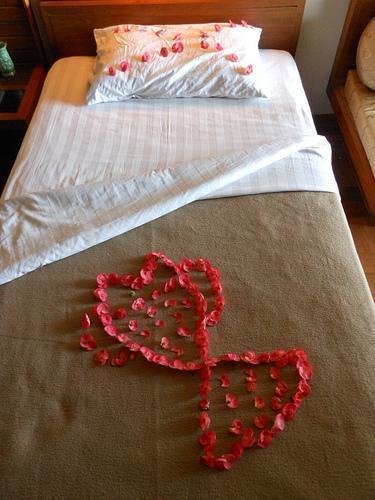How many pillows are on the bed?
Give a very brief answer. 1. 